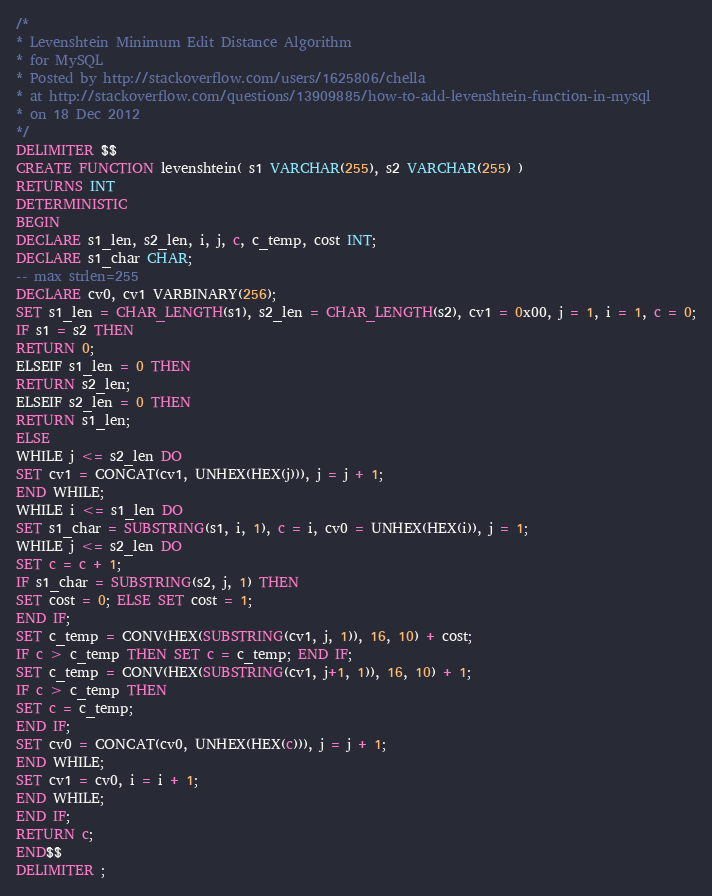Convert code to text. <code><loc_0><loc_0><loc_500><loc_500><_SQL_>/*
* Levenshtein Minimum Edit Distance Algorithm
* for MySQL
* Posted by http://stackoverflow.com/users/1625806/chella
* at http://stackoverflow.com/questions/13909885/how-to-add-levenshtein-function-in-mysql
* on 18 Dec 2012
*/
DELIMITER $$
CREATE FUNCTION levenshtein( s1 VARCHAR(255), s2 VARCHAR(255) )
RETURNS INT
DETERMINISTIC
BEGIN
DECLARE s1_len, s2_len, i, j, c, c_temp, cost INT;
DECLARE s1_char CHAR;
-- max strlen=255
DECLARE cv0, cv1 VARBINARY(256);
SET s1_len = CHAR_LENGTH(s1), s2_len = CHAR_LENGTH(s2), cv1 = 0x00, j = 1, i = 1, c = 0;
IF s1 = s2 THEN
RETURN 0;
ELSEIF s1_len = 0 THEN
RETURN s2_len;
ELSEIF s2_len = 0 THEN
RETURN s1_len;
ELSE
WHILE j <= s2_len DO
SET cv1 = CONCAT(cv1, UNHEX(HEX(j))), j = j + 1;
END WHILE;
WHILE i <= s1_len DO
SET s1_char = SUBSTRING(s1, i, 1), c = i, cv0 = UNHEX(HEX(i)), j = 1;
WHILE j <= s2_len DO
SET c = c + 1;
IF s1_char = SUBSTRING(s2, j, 1) THEN
SET cost = 0; ELSE SET cost = 1;
END IF;
SET c_temp = CONV(HEX(SUBSTRING(cv1, j, 1)), 16, 10) + cost;
IF c > c_temp THEN SET c = c_temp; END IF;
SET c_temp = CONV(HEX(SUBSTRING(cv1, j+1, 1)), 16, 10) + 1;
IF c > c_temp THEN
SET c = c_temp;
END IF;
SET cv0 = CONCAT(cv0, UNHEX(HEX(c))), j = j + 1;
END WHILE;
SET cv1 = cv0, i = i + 1;
END WHILE;
END IF;
RETURN c;
END$$
DELIMITER ;</code> 